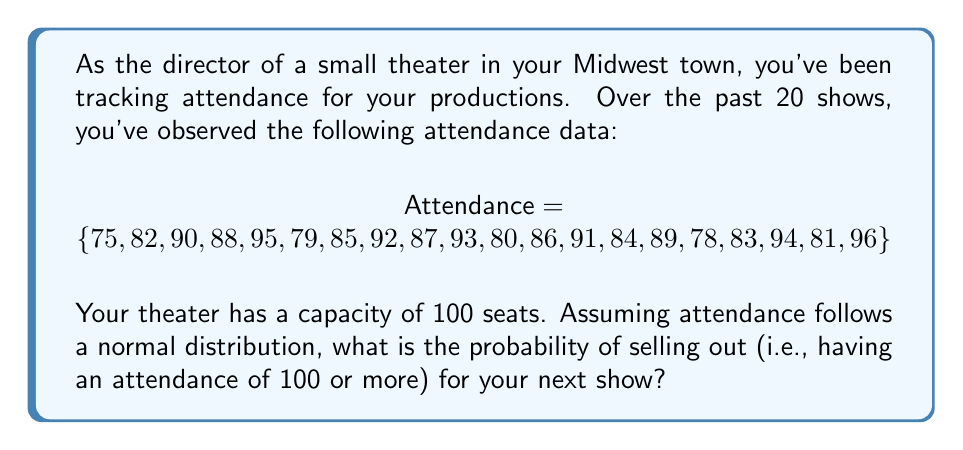Teach me how to tackle this problem. To solve this problem, we'll follow these steps:

1) First, we need to calculate the mean ($\mu$) and standard deviation ($\sigma$) of the attendance data.

   Mean: $\mu = \frac{\sum_{i=1}^{n} x_i}{n} = \frac{1728}{20} = 86.4$

   Standard deviation: $\sigma = \sqrt{\frac{\sum_{i=1}^{n} (x_i - \mu)^2}{n-1}}$
   
   After calculation, we get $\sigma \approx 6.0331$

2) We want to find $P(X \geq 100)$, where $X$ is the attendance for the next show.

3) We can standardize this to a z-score:
   
   $z = \frac{x - \mu}{\sigma} = \frac{100 - 86.4}{6.0331} \approx 2.2542$

4) Now, we need to find $P(Z \geq 2.2542)$, where $Z$ is a standard normal random variable.

5) Using a standard normal table or calculator, we can find that:
   
   $P(Z \leq 2.2542) \approx 0.9879$

6) Therefore, $P(Z \geq 2.2542) = 1 - P(Z \leq 2.2542) \approx 1 - 0.9879 = 0.0121$

So, the probability of selling out (having an attendance of 100 or more) is approximately 0.0121 or 1.21%.
Answer: 0.0121 or 1.21% 